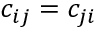Convert formula to latex. <formula><loc_0><loc_0><loc_500><loc_500>c _ { i j } = c _ { j i }</formula> 